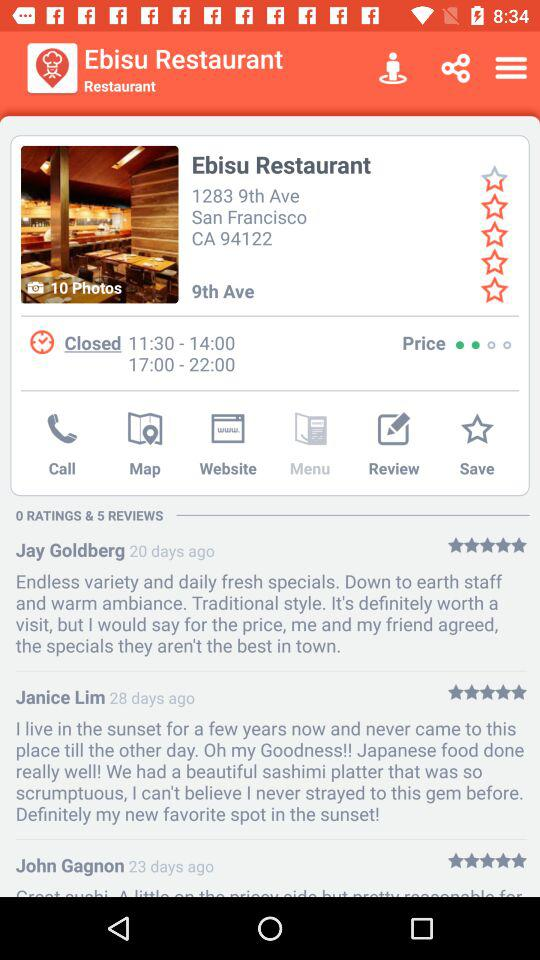What is the star rating given to "Ebisu Restaurant"? The rating given to "Ebisu Restaurant" is 4.5 stars. 